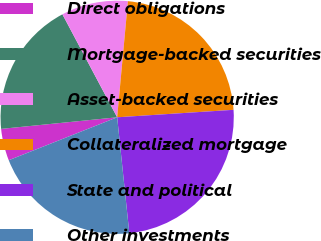Convert chart. <chart><loc_0><loc_0><loc_500><loc_500><pie_chart><fcel>Direct obligations<fcel>Mortgage-backed securities<fcel>Asset-backed securities<fcel>Collateralized mortgage<fcel>State and political<fcel>Other investments<nl><fcel>4.42%<fcel>18.81%<fcel>9.25%<fcel>22.51%<fcel>24.36%<fcel>20.66%<nl></chart> 